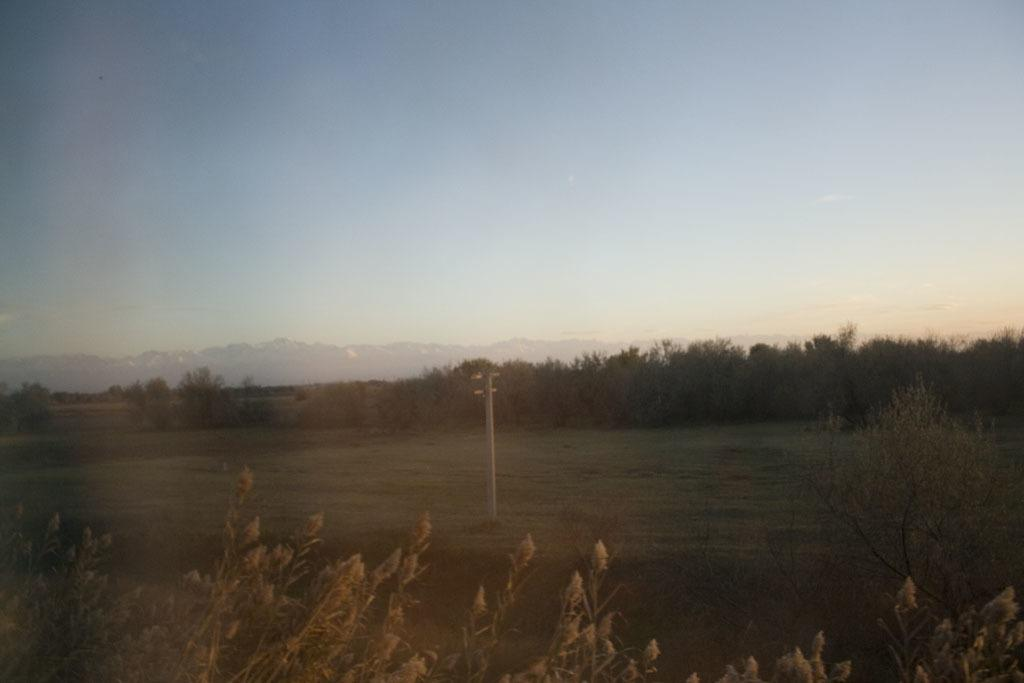What is the main object in the center of the image? There is a pole in the center of the image. What type of natural elements can be seen in the image? Trees and hills are visible in the image. What is at the top of the image? The sky is at the top of the image. What is at the bottom of the image? Plants and the ground are at the bottom of the image. Can you hear the owl cry in the image? There is no owl or any sound present in the image, so it is not possible to hear an owl cry. 